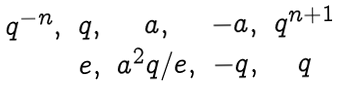Convert formula to latex. <formula><loc_0><loc_0><loc_500><loc_500>\begin{matrix} q ^ { - n } , & q , & a , & - a , & q ^ { n + 1 } \\ & e , & a ^ { 2 } q / e , & - q , & q \end{matrix}</formula> 